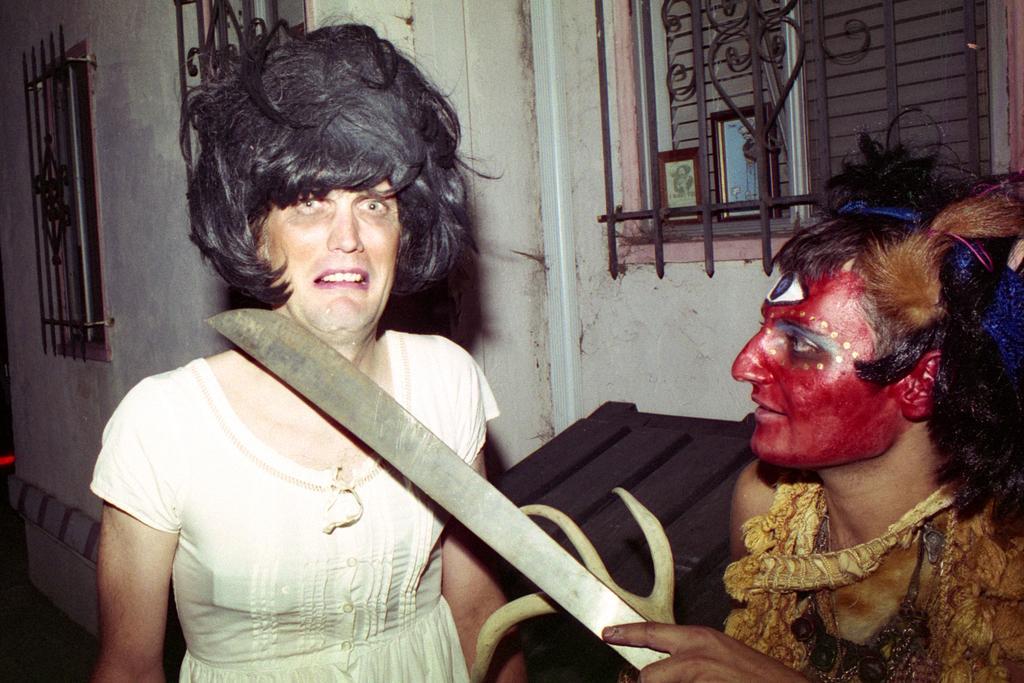Describe this image in one or two sentences. In this image there are two people in the foreground. There is a wall with windows and grills in the background. 